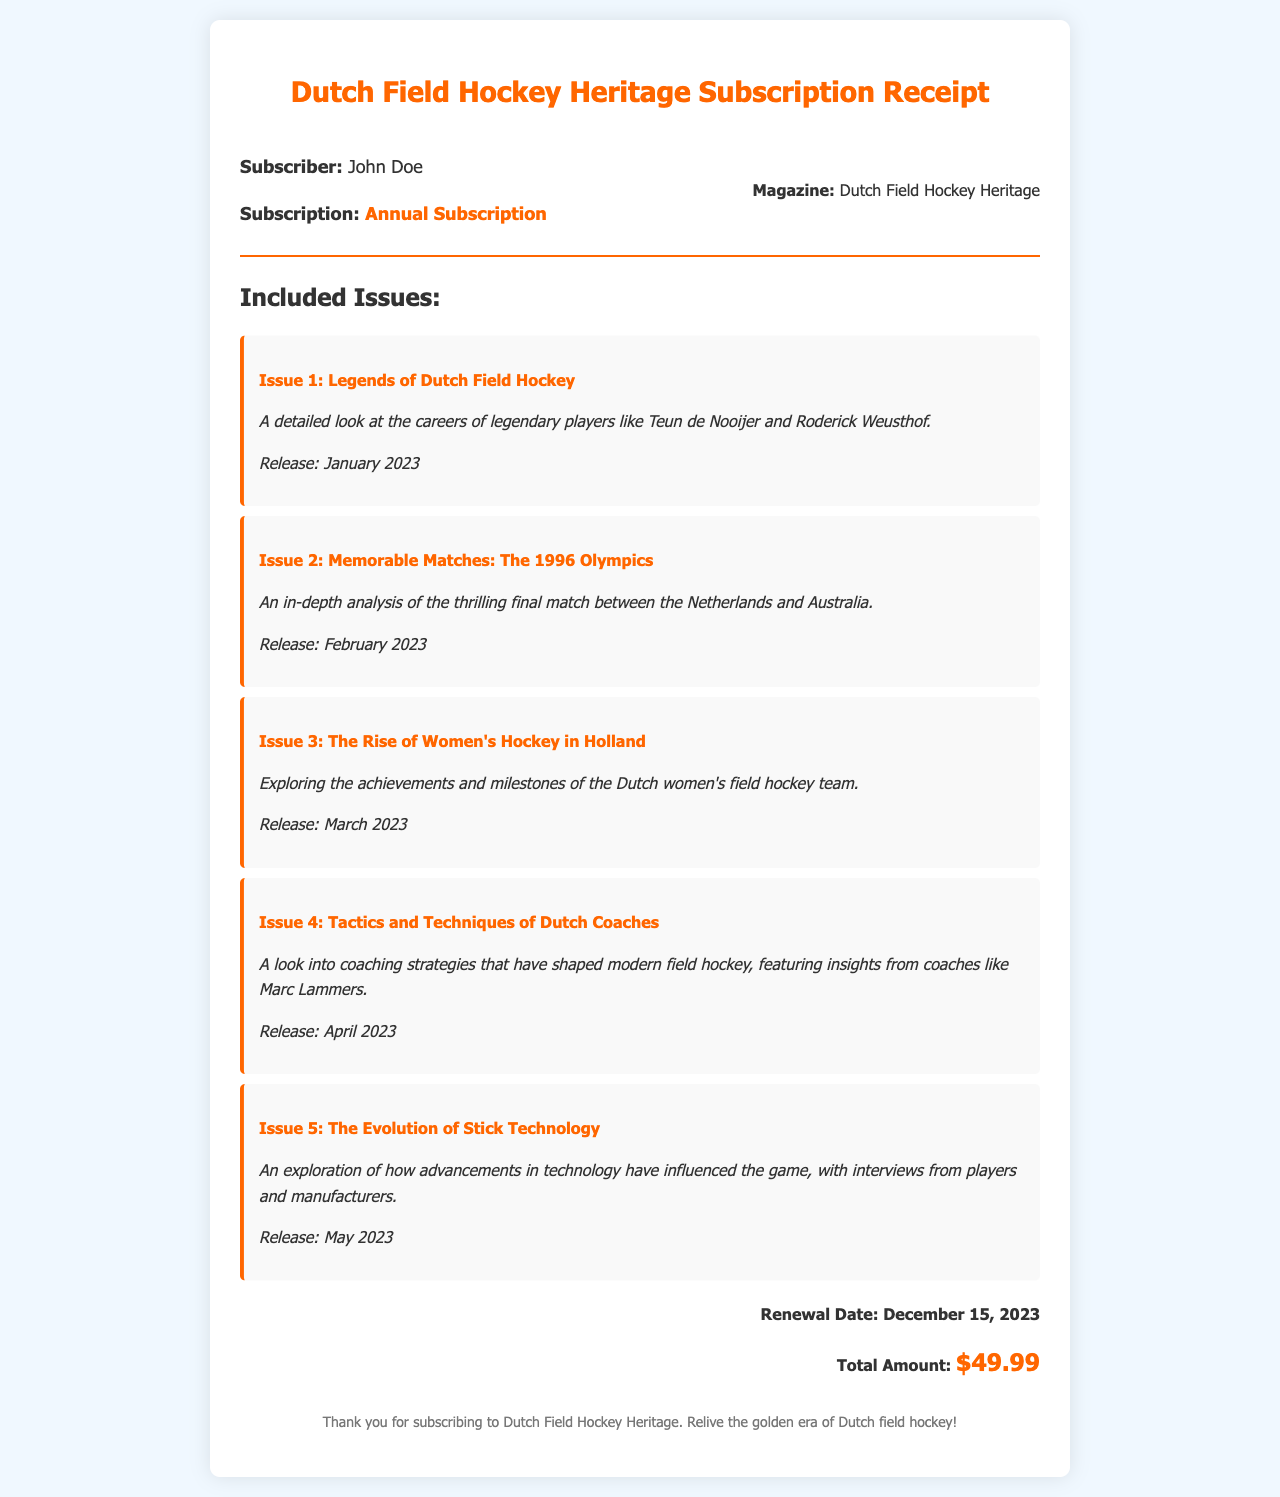What is the name of the magazine? The name of the magazine is mentioned clearly in the document as "Dutch Field Hockey Heritage."
Answer: Dutch Field Hockey Heritage Who is the subscriber's name? The subscriber's name is stated in the receipt as "John Doe."
Answer: John Doe What is the subscription type? The subscription type is specified in the document as "Annual Subscription."
Answer: Annual Subscription How many issues are included in the subscription? The document lists a total of 5 issues included in the subscription.
Answer: 5 What is the renewal date? The renewal date is provided in the receipt as "December 15, 2023."
Answer: December 15, 2023 What is the total amount for the subscription? The total amount is clearly indicated in the document as "$49.99."
Answer: $49.99 What was the focus of Issue 2? The focus of Issue 2 is described as "An in-depth analysis of the thrilling final match between the Netherlands and Australia."
Answer: Final match analysis What is the release month of Issue 4? The document states that Issue 4 was released in "April 2023."
Answer: April 2023 Who is featured in Issue 4 regarding coaching strategies? The issue mentions insights from "Marc Lammers" regarding coaching strategies.
Answer: Marc Lammers 